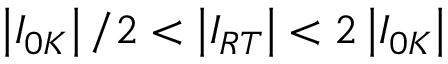Convert formula to latex. <formula><loc_0><loc_0><loc_500><loc_500>\left | I _ { 0 K } \right | / 2 < \left | I _ { R T } \right | < 2 \left | I _ { 0 K } \right |</formula> 